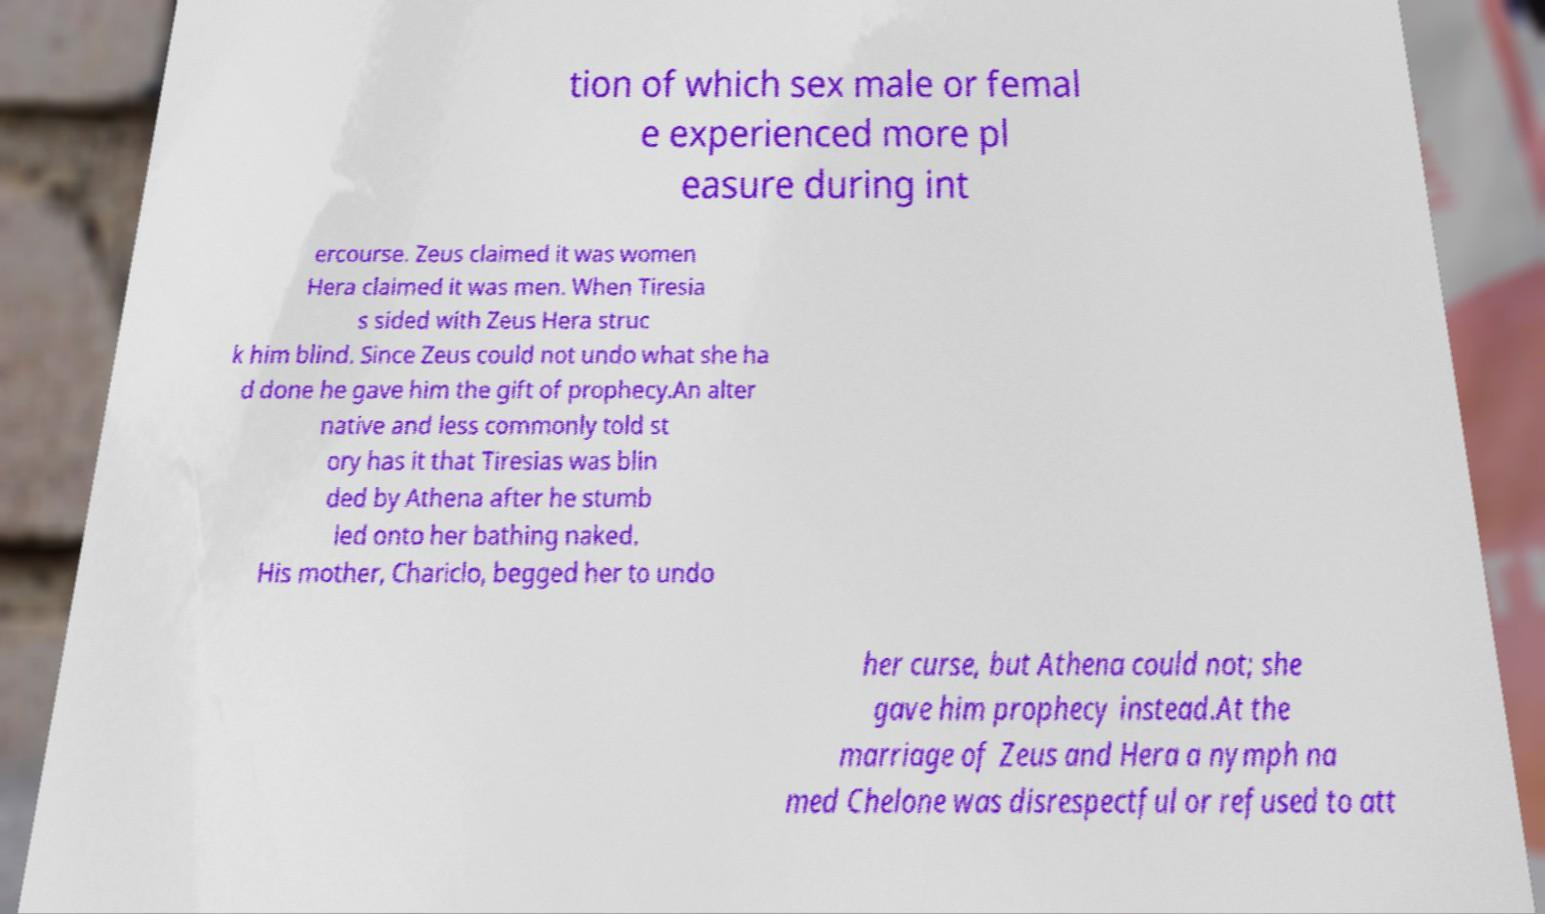There's text embedded in this image that I need extracted. Can you transcribe it verbatim? tion of which sex male or femal e experienced more pl easure during int ercourse. Zeus claimed it was women Hera claimed it was men. When Tiresia s sided with Zeus Hera struc k him blind. Since Zeus could not undo what she ha d done he gave him the gift of prophecy.An alter native and less commonly told st ory has it that Tiresias was blin ded by Athena after he stumb led onto her bathing naked. His mother, Chariclo, begged her to undo her curse, but Athena could not; she gave him prophecy instead.At the marriage of Zeus and Hera a nymph na med Chelone was disrespectful or refused to att 